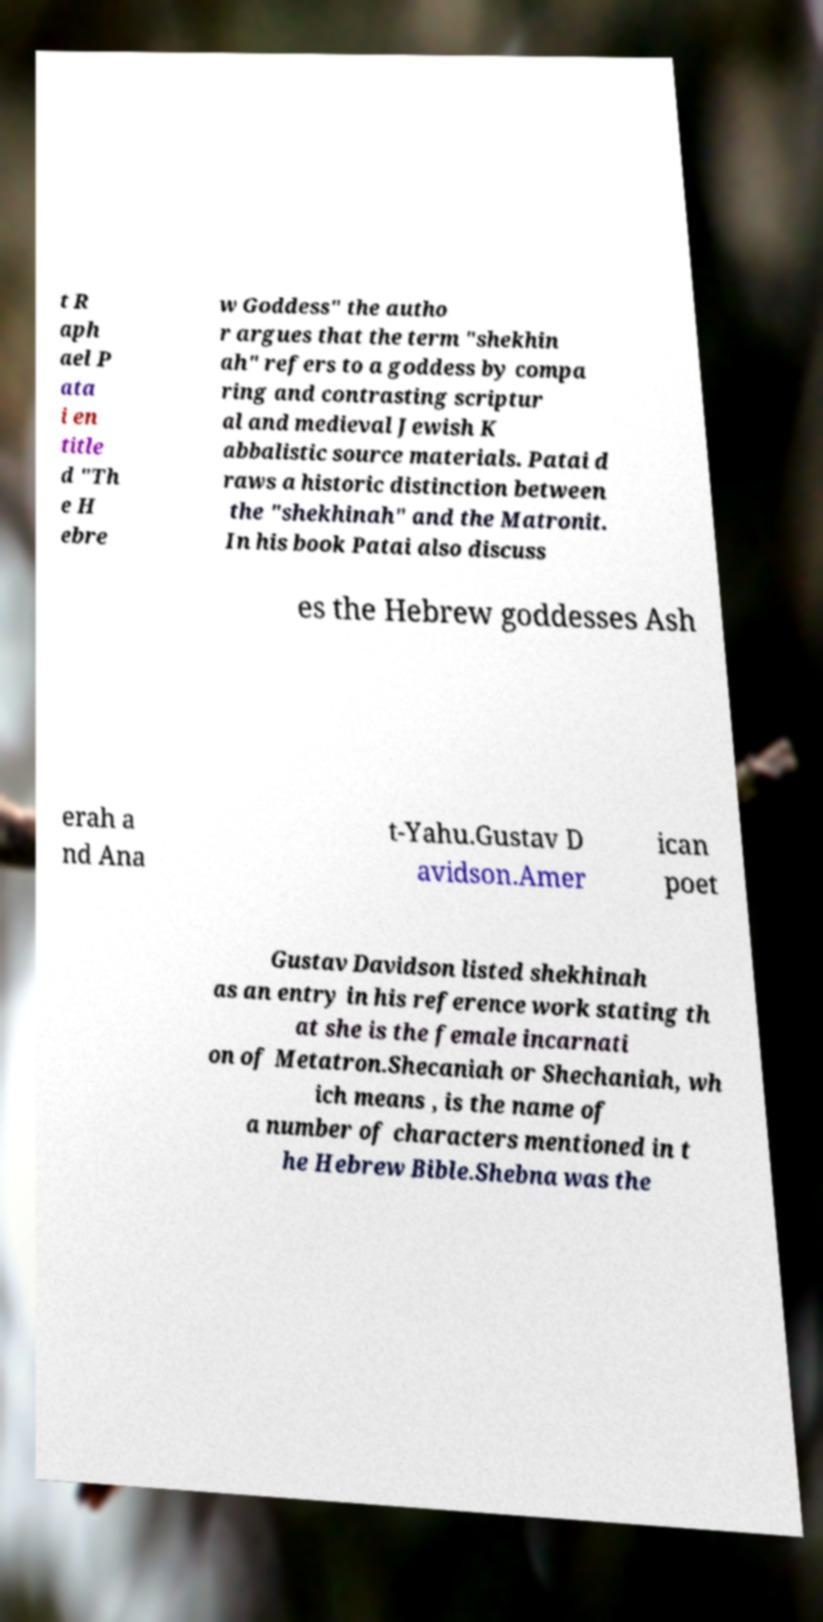Can you accurately transcribe the text from the provided image for me? t R aph ael P ata i en title d "Th e H ebre w Goddess" the autho r argues that the term "shekhin ah" refers to a goddess by compa ring and contrasting scriptur al and medieval Jewish K abbalistic source materials. Patai d raws a historic distinction between the "shekhinah" and the Matronit. In his book Patai also discuss es the Hebrew goddesses Ash erah a nd Ana t-Yahu.Gustav D avidson.Amer ican poet Gustav Davidson listed shekhinah as an entry in his reference work stating th at she is the female incarnati on of Metatron.Shecaniah or Shechaniah, wh ich means , is the name of a number of characters mentioned in t he Hebrew Bible.Shebna was the 